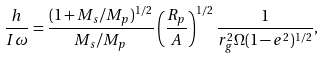<formula> <loc_0><loc_0><loc_500><loc_500>\frac { h } { I \omega } = \frac { ( 1 + M _ { s } / M _ { p } ) ^ { 1 / 2 } } { M _ { s } / M _ { p } } \left ( \frac { R _ { p } } { A } \right ) ^ { 1 / 2 } \frac { 1 } { r _ { g } ^ { 2 } \Omega ( 1 - e ^ { 2 } ) ^ { 1 / 2 } } ,</formula> 